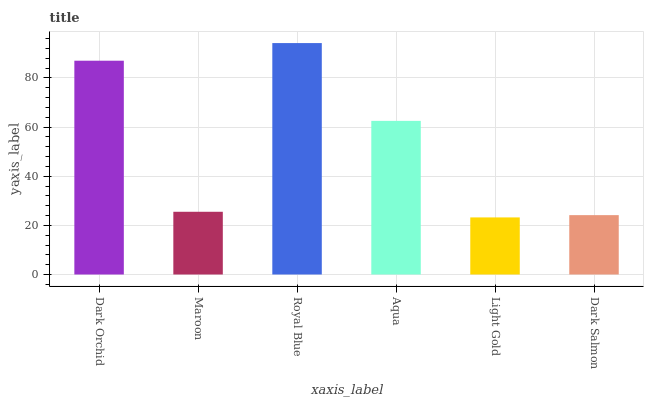Is Light Gold the minimum?
Answer yes or no. Yes. Is Royal Blue the maximum?
Answer yes or no. Yes. Is Maroon the minimum?
Answer yes or no. No. Is Maroon the maximum?
Answer yes or no. No. Is Dark Orchid greater than Maroon?
Answer yes or no. Yes. Is Maroon less than Dark Orchid?
Answer yes or no. Yes. Is Maroon greater than Dark Orchid?
Answer yes or no. No. Is Dark Orchid less than Maroon?
Answer yes or no. No. Is Aqua the high median?
Answer yes or no. Yes. Is Maroon the low median?
Answer yes or no. Yes. Is Dark Orchid the high median?
Answer yes or no. No. Is Aqua the low median?
Answer yes or no. No. 